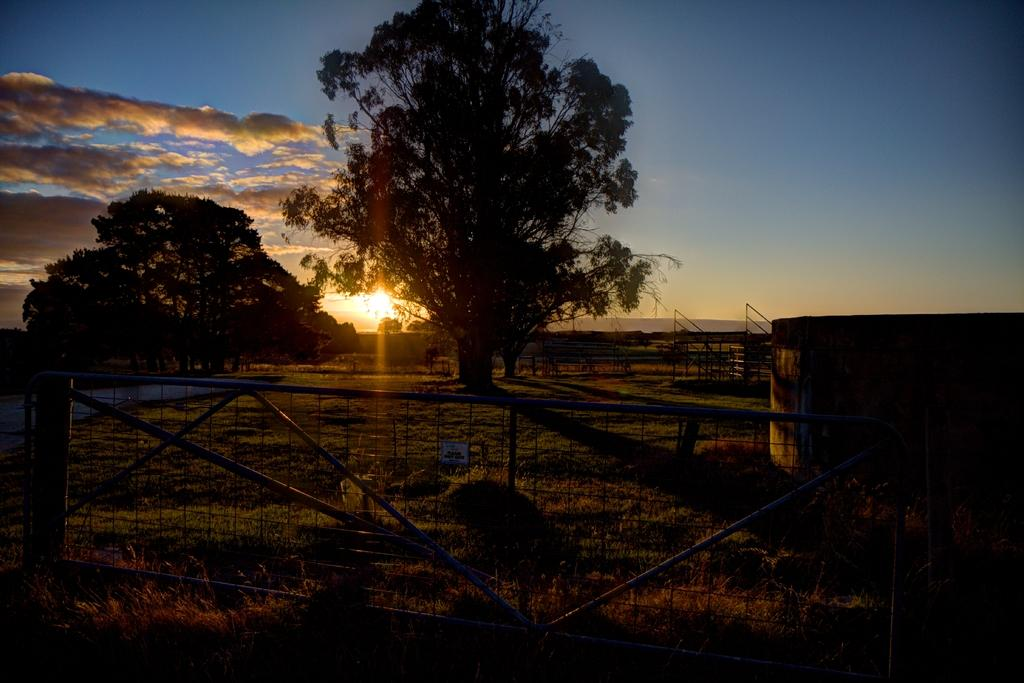What is located in the center of the image? There are trees in the center of the image. What can be seen at the bottom of the image? There is a fence at the bottom of the image. What type of vegetation is visible in the image? Grass is visible in the image. What is visible in the background of the image? There is sky in the background of the image. What celestial body can be seen in the sky? The sun is visible in the sky. Can you tell me how many geese are flying in the sky in the image? There are no geese visible in the image; only trees, a fence, grass, sky, and the sun are present. 